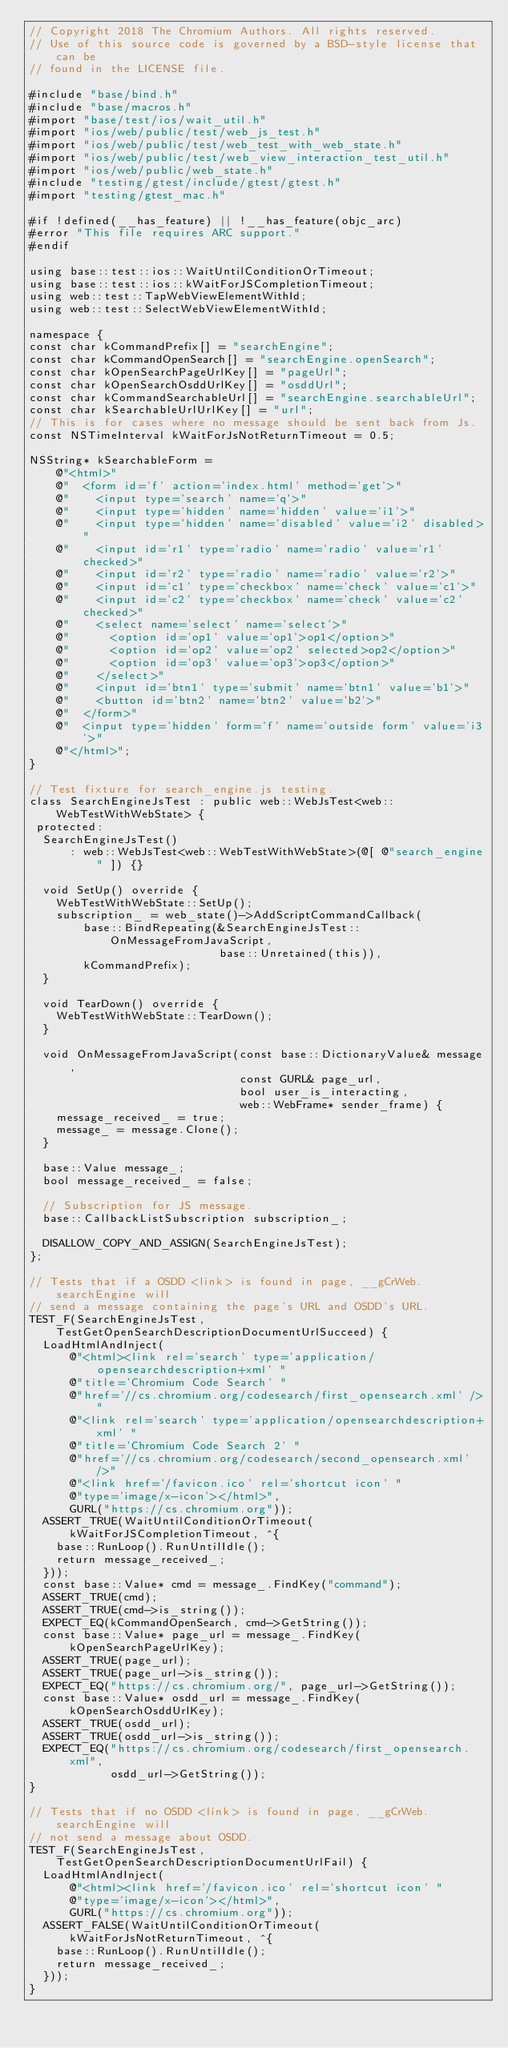<code> <loc_0><loc_0><loc_500><loc_500><_ObjectiveC_>// Copyright 2018 The Chromium Authors. All rights reserved.
// Use of this source code is governed by a BSD-style license that can be
// found in the LICENSE file.

#include "base/bind.h"
#include "base/macros.h"
#import "base/test/ios/wait_util.h"
#import "ios/web/public/test/web_js_test.h"
#import "ios/web/public/test/web_test_with_web_state.h"
#import "ios/web/public/test/web_view_interaction_test_util.h"
#import "ios/web/public/web_state.h"
#include "testing/gtest/include/gtest/gtest.h"
#import "testing/gtest_mac.h"

#if !defined(__has_feature) || !__has_feature(objc_arc)
#error "This file requires ARC support."
#endif

using base::test::ios::WaitUntilConditionOrTimeout;
using base::test::ios::kWaitForJSCompletionTimeout;
using web::test::TapWebViewElementWithId;
using web::test::SelectWebViewElementWithId;

namespace {
const char kCommandPrefix[] = "searchEngine";
const char kCommandOpenSearch[] = "searchEngine.openSearch";
const char kOpenSearchPageUrlKey[] = "pageUrl";
const char kOpenSearchOsddUrlKey[] = "osddUrl";
const char kCommandSearchableUrl[] = "searchEngine.searchableUrl";
const char kSearchableUrlUrlKey[] = "url";
// This is for cases where no message should be sent back from Js.
const NSTimeInterval kWaitForJsNotReturnTimeout = 0.5;

NSString* kSearchableForm =
    @"<html>"
    @"  <form id='f' action='index.html' method='get'>"
    @"    <input type='search' name='q'>"
    @"    <input type='hidden' name='hidden' value='i1'>"
    @"    <input type='hidden' name='disabled' value='i2' disabled>"
    @"    <input id='r1' type='radio' name='radio' value='r1' checked>"
    @"    <input id='r2' type='radio' name='radio' value='r2'>"
    @"    <input id='c1' type='checkbox' name='check' value='c1'>"
    @"    <input id='c2' type='checkbox' name='check' value='c2' checked>"
    @"    <select name='select' name='select'>"
    @"      <option id='op1' value='op1'>op1</option>"
    @"      <option id='op2' value='op2' selected>op2</option>"
    @"      <option id='op3' value='op3'>op3</option>"
    @"    </select>"
    @"    <input id='btn1' type='submit' name='btn1' value='b1'>"
    @"    <button id='btn2' name='btn2' value='b2'>"
    @"  </form>"
    @"  <input type='hidden' form='f' name='outside form' value='i3'>"
    @"</html>";
}

// Test fixture for search_engine.js testing.
class SearchEngineJsTest : public web::WebJsTest<web::WebTestWithWebState> {
 protected:
  SearchEngineJsTest()
      : web::WebJsTest<web::WebTestWithWebState>(@[ @"search_engine" ]) {}

  void SetUp() override {
    WebTestWithWebState::SetUp();
    subscription_ = web_state()->AddScriptCommandCallback(
        base::BindRepeating(&SearchEngineJsTest::OnMessageFromJavaScript,
                            base::Unretained(this)),
        kCommandPrefix);
  }

  void TearDown() override {
    WebTestWithWebState::TearDown();
  }

  void OnMessageFromJavaScript(const base::DictionaryValue& message,
                               const GURL& page_url,
                               bool user_is_interacting,
                               web::WebFrame* sender_frame) {
    message_received_ = true;
    message_ = message.Clone();
  }

  base::Value message_;
  bool message_received_ = false;

  // Subscription for JS message.
  base::CallbackListSubscription subscription_;

  DISALLOW_COPY_AND_ASSIGN(SearchEngineJsTest);
};

// Tests that if a OSDD <link> is found in page, __gCrWeb.searchEngine will
// send a message containing the page's URL and OSDD's URL.
TEST_F(SearchEngineJsTest, TestGetOpenSearchDescriptionDocumentUrlSucceed) {
  LoadHtmlAndInject(
      @"<html><link rel='search' type='application/opensearchdescription+xml' "
      @"title='Chromium Code Search' "
      @"href='//cs.chromium.org/codesearch/first_opensearch.xml' />"
      @"<link rel='search' type='application/opensearchdescription+xml' "
      @"title='Chromium Code Search 2' "
      @"href='//cs.chromium.org/codesearch/second_opensearch.xml' />"
      @"<link href='/favicon.ico' rel='shortcut icon' "
      @"type='image/x-icon'></html>",
      GURL("https://cs.chromium.org"));
  ASSERT_TRUE(WaitUntilConditionOrTimeout(kWaitForJSCompletionTimeout, ^{
    base::RunLoop().RunUntilIdle();
    return message_received_;
  }));
  const base::Value* cmd = message_.FindKey("command");
  ASSERT_TRUE(cmd);
  ASSERT_TRUE(cmd->is_string());
  EXPECT_EQ(kCommandOpenSearch, cmd->GetString());
  const base::Value* page_url = message_.FindKey(kOpenSearchPageUrlKey);
  ASSERT_TRUE(page_url);
  ASSERT_TRUE(page_url->is_string());
  EXPECT_EQ("https://cs.chromium.org/", page_url->GetString());
  const base::Value* osdd_url = message_.FindKey(kOpenSearchOsddUrlKey);
  ASSERT_TRUE(osdd_url);
  ASSERT_TRUE(osdd_url->is_string());
  EXPECT_EQ("https://cs.chromium.org/codesearch/first_opensearch.xml",
            osdd_url->GetString());
}

// Tests that if no OSDD <link> is found in page, __gCrWeb.searchEngine will
// not send a message about OSDD.
TEST_F(SearchEngineJsTest, TestGetOpenSearchDescriptionDocumentUrlFail) {
  LoadHtmlAndInject(
      @"<html><link href='/favicon.ico' rel='shortcut icon' "
      @"type='image/x-icon'></html>",
      GURL("https://cs.chromium.org"));
  ASSERT_FALSE(WaitUntilConditionOrTimeout(kWaitForJsNotReturnTimeout, ^{
    base::RunLoop().RunUntilIdle();
    return message_received_;
  }));
}
</code> 